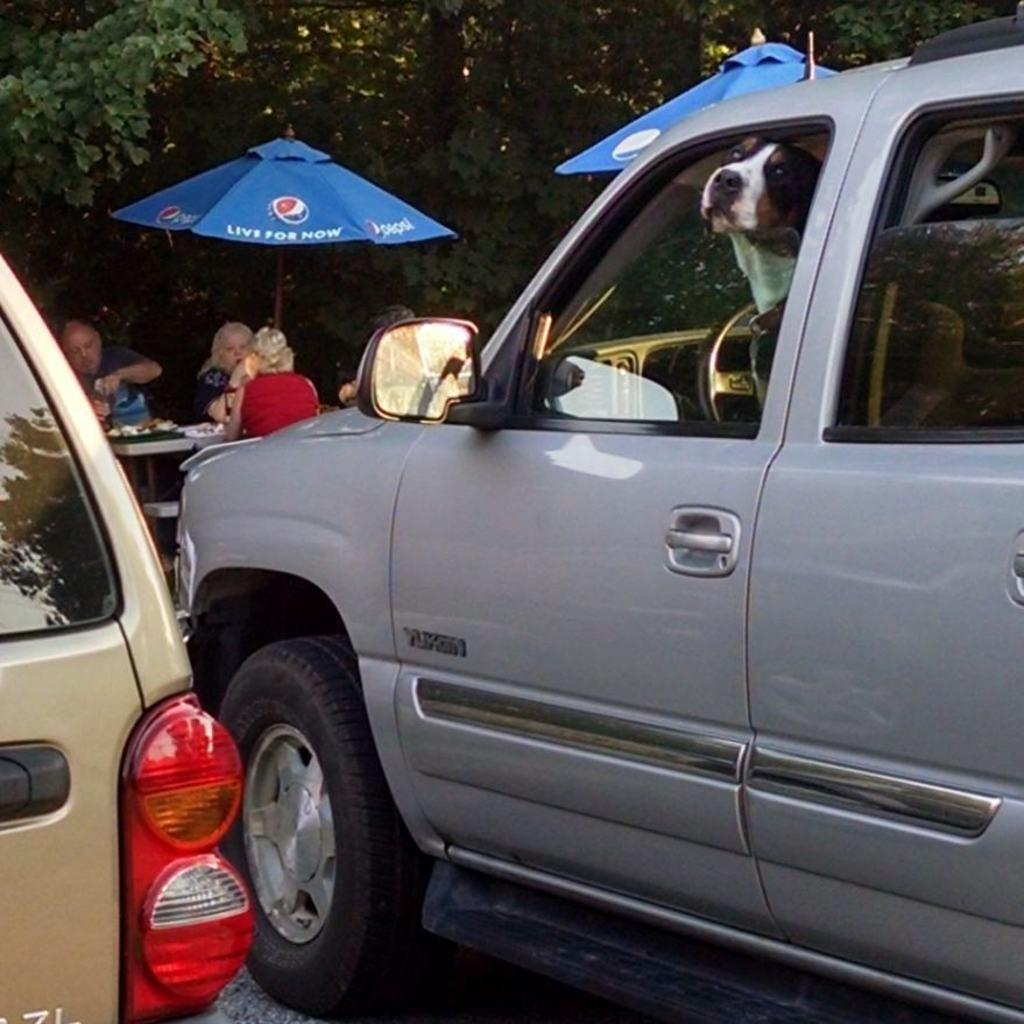What can be seen in the image besides the people sitting around the table? There are two vehicles in the image. What are the people doing at the table? The people are having food. What can be seen in the background of the image? There are trees in the background of the image. What type of orange advertisement can be seen on the vehicles in the image? There is no orange advertisement present on the vehicles in the image. What is the hose used for in the image? There is no hose present in the image. 